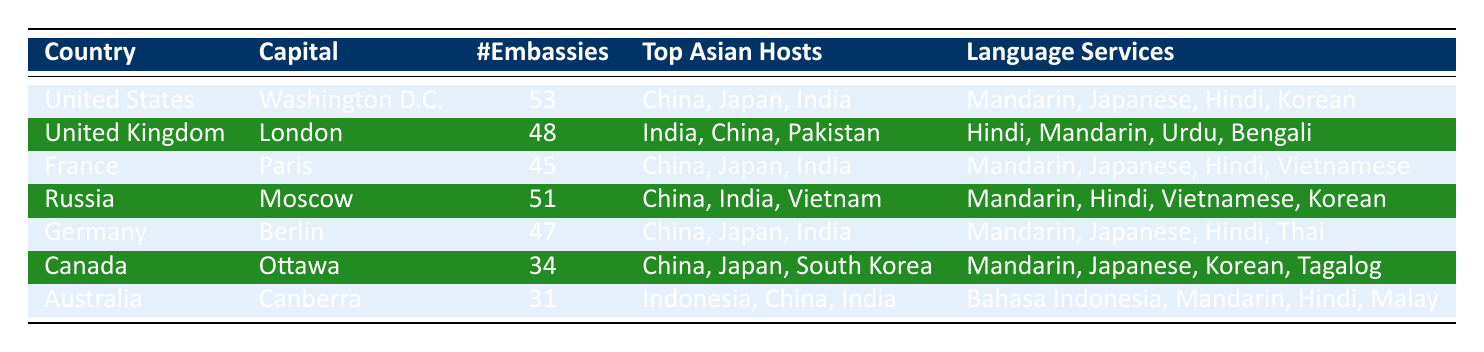What country has the highest number of embassies in Asia? The table lists the number of embassies for each country. The United States has 53 embassies, which is the highest compared to the others.
Answer: United States Which two countries share the same number of embassies in Asia? The United Kingdom has 48 embassies and France has 45 embassies. No two countries share the same number of embassies.
Answer: No What is the total number of embassies represented by the countries listed? To find the total, add the number of embassies: 53 + 48 + 45 + 51 + 47 + 34 + 31 = 309.
Answer: 309 Does Canada offer language services in Mandarin? Checking the Language Services Offered for Canada shows "Mandarin, Japanese, Korean, Tagalog." Thus, Canada does offer language services in Mandarin.
Answer: Yes Which country offers the most diverse language services? To find the most diverse language services, review the "Language Services Offered" column. The United States offers four languages: Mandarin, Japanese, Hindi, and Korean, which is the highest count.
Answer: United States What is the average number of embassies among the countries listed in the table? To find the average number of embassies, sum the total (309 from the previous calculation) and divide it by the number of countries (7): 309/7 = 44.14, which rounds to approximately 44.
Answer: 44 Are the top Asian host countries for Germany the same as those for the United Kingdom? Germany's top Asian host countries are China, Japan, India; the UK's are India, China, Pakistan. Since they both mention China and India but differ with Japan and Pakistan, they are not the same.
Answer: No Which country has the least number of embassies in Asia? The table indicates Canada with 34 embassies, which is the least among the listed countries.
Answer: Canada What language services are offered by Russia? By looking at the table, Russia offers "Mandarin, Hindi, Vietnamese, Korean." This indicates a range of language services.
Answer: Mandarin, Hindi, Vietnamese, Korean 